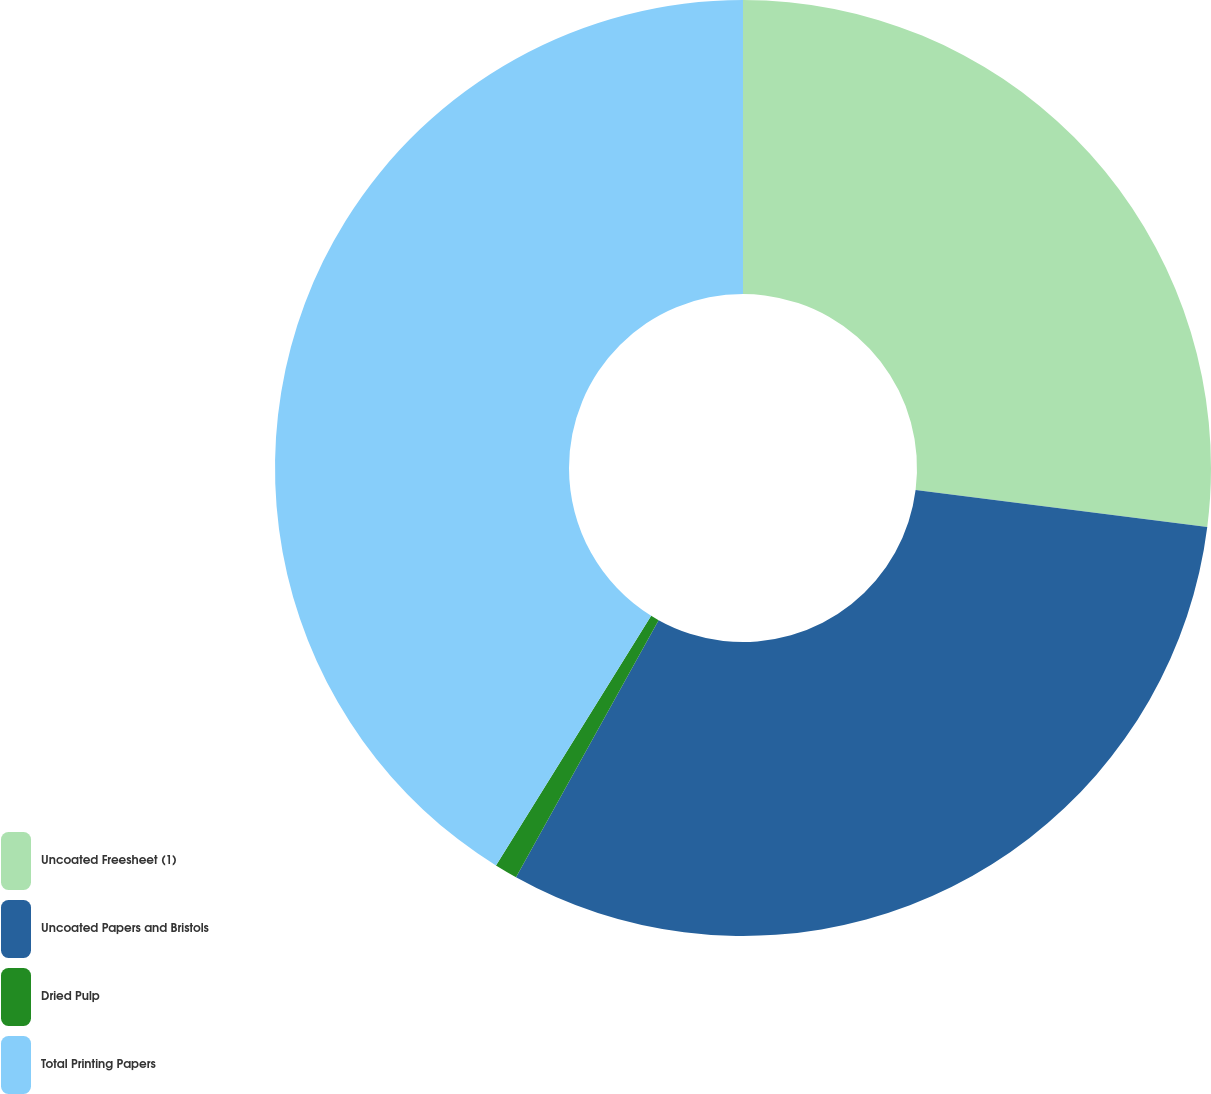Convert chart to OTSL. <chart><loc_0><loc_0><loc_500><loc_500><pie_chart><fcel>Uncoated Freesheet (1)<fcel>Uncoated Papers and Bristols<fcel>Dried Pulp<fcel>Total Printing Papers<nl><fcel>27.01%<fcel>31.05%<fcel>0.79%<fcel>41.15%<nl></chart> 